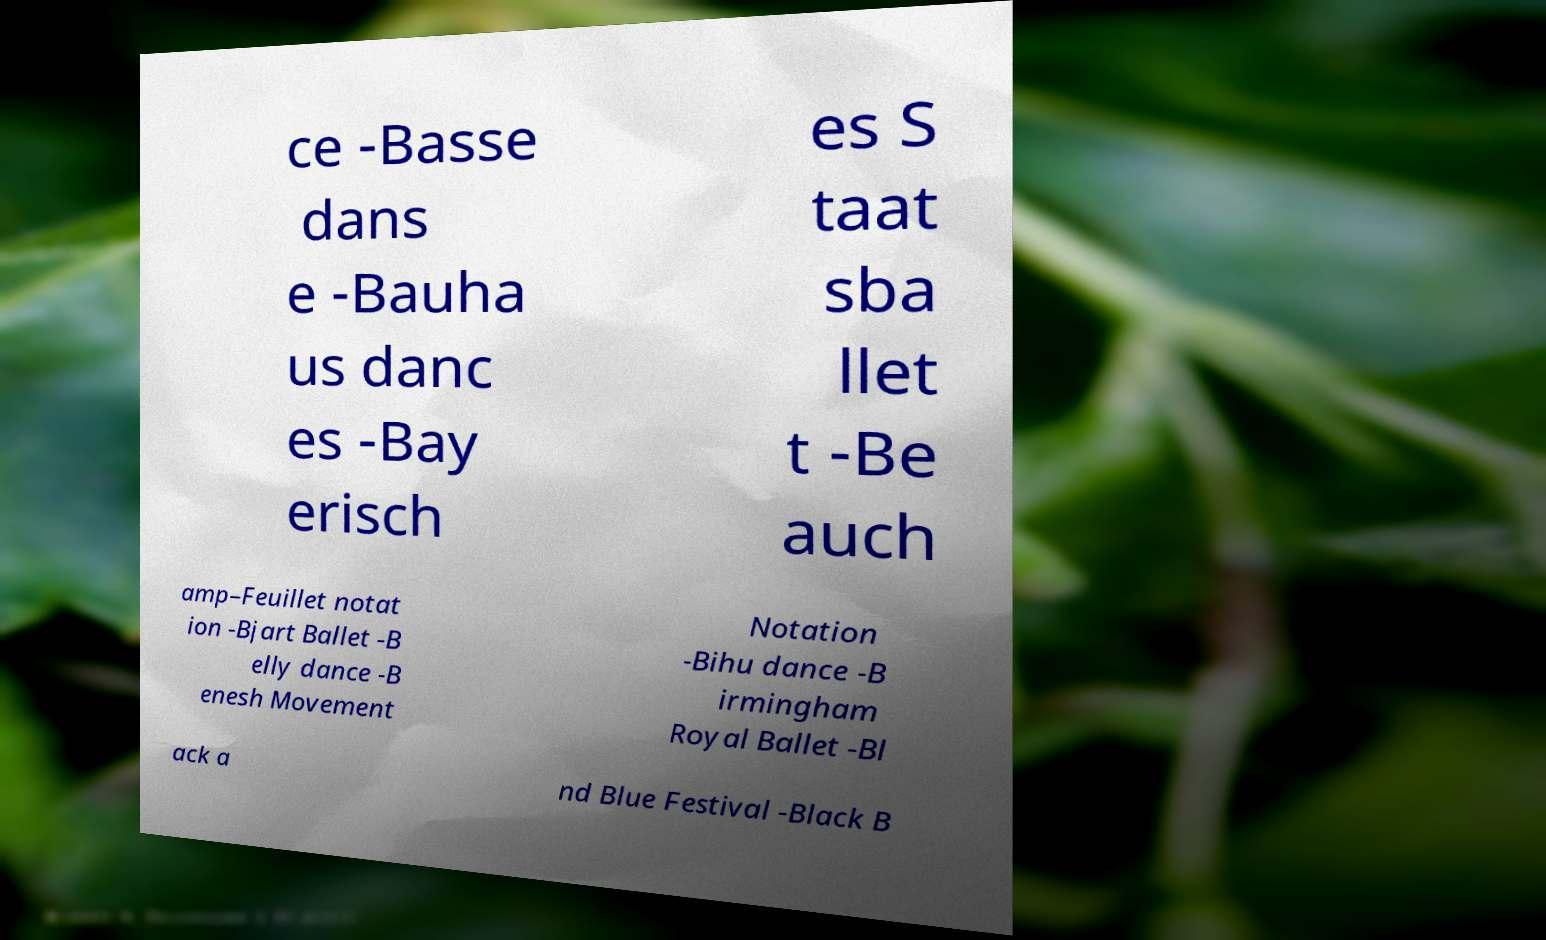For documentation purposes, I need the text within this image transcribed. Could you provide that? ce -Basse dans e -Bauha us danc es -Bay erisch es S taat sba llet t -Be auch amp–Feuillet notat ion -Bjart Ballet -B elly dance -B enesh Movement Notation -Bihu dance -B irmingham Royal Ballet -Bl ack a nd Blue Festival -Black B 